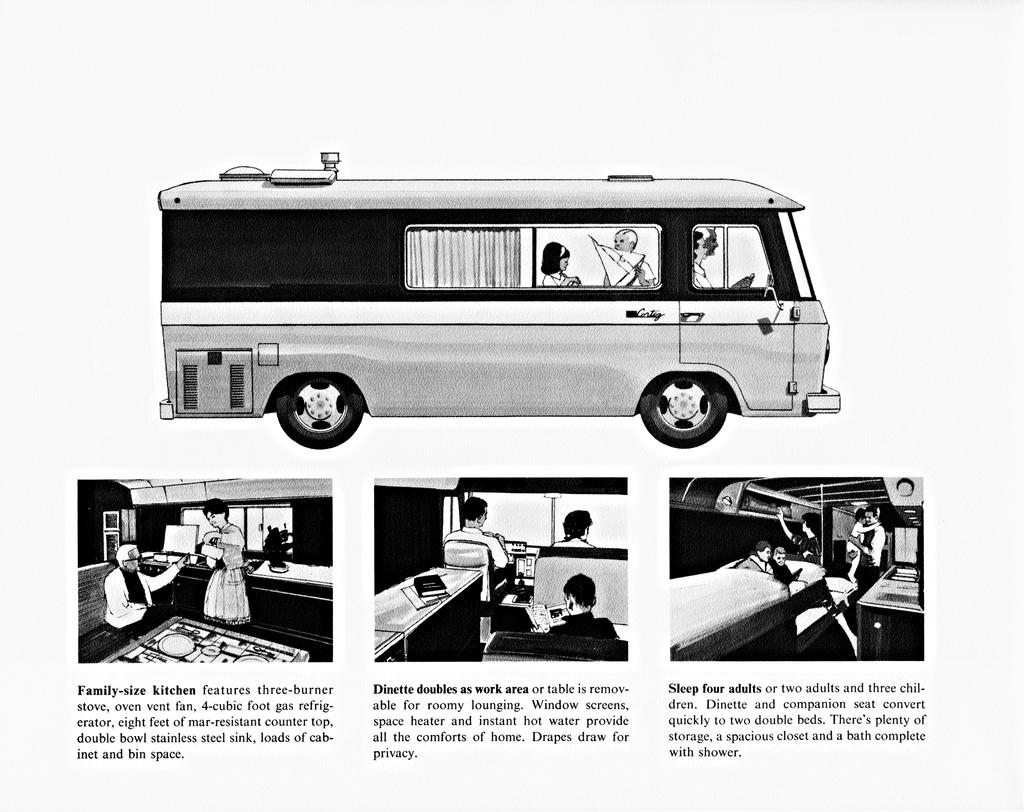<image>
Create a compact narrative representing the image presented. An advertisement for a trailer which features a family sized kitchen. 